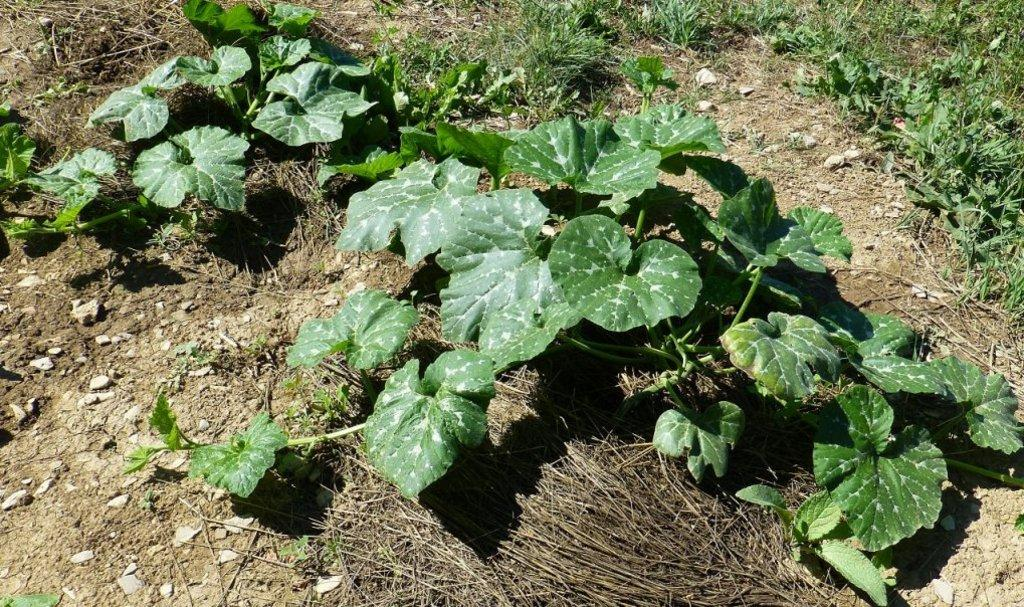What type of vegetation can be seen on the surface in the image? There are leaves on the surface in the image. What other natural elements can be observed in the image? There is dry grass visible in the image. What book is being read by the leaves in the image? There is no book present in the image, as it features leaves and dry grass. 